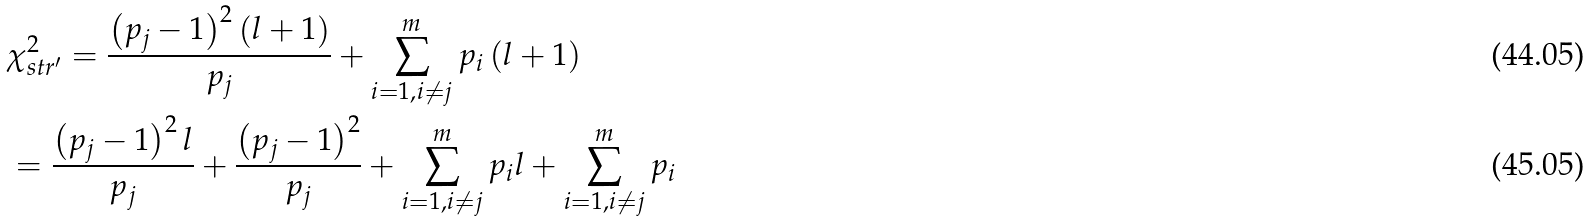<formula> <loc_0><loc_0><loc_500><loc_500>& \chi ^ { 2 } _ { s t r ^ { \prime } } = \frac { \left ( p _ { j } - 1 \right ) ^ { 2 } \left ( l + 1 \right ) } { p _ { j } } + \sum ^ { m } _ { i = 1 , i \neq j } p _ { i } \left ( l + 1 \right ) \\ & = \frac { \left ( p _ { j } - 1 \right ) ^ { 2 } l } { p _ { j } } + \frac { \left ( p _ { j } - 1 \right ) ^ { 2 } } { p _ { j } } + \sum ^ { m } _ { i = 1 , i \neq j } p _ { i } l + \sum ^ { m } _ { i = 1 , i \neq j } p _ { i }</formula> 